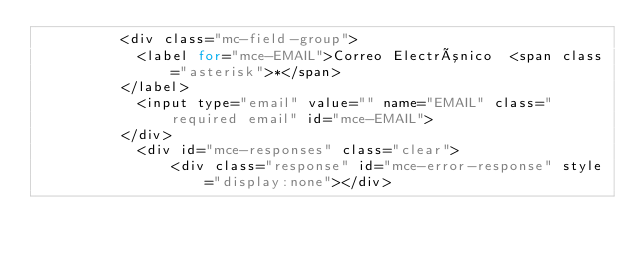Convert code to text. <code><loc_0><loc_0><loc_500><loc_500><_PHP_>          <div class="mc-field-group">
          	<label for="mce-EMAIL">Correo Electrónico  <span class="asterisk">*</span>
          </label>
          	<input type="email" value="" name="EMAIL" class="required email" id="mce-EMAIL">
          </div>
          	<div id="mce-responses" class="clear">
          		<div class="response" id="mce-error-response" style="display:none"></div></code> 